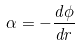Convert formula to latex. <formula><loc_0><loc_0><loc_500><loc_500>\alpha = - \frac { d \phi } { d r }</formula> 